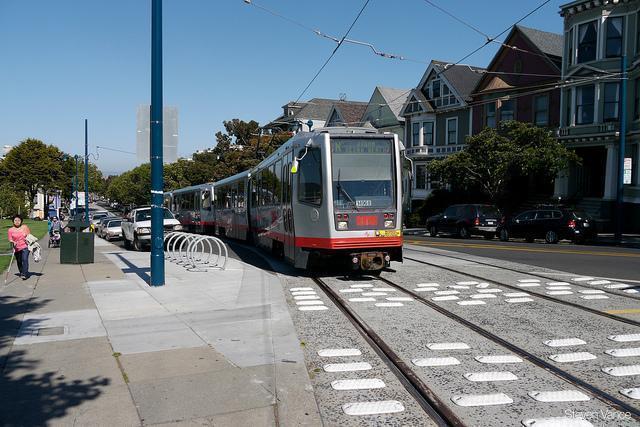The person nearest has what handicap?
Indicate the correct response and explain using: 'Answer: answer
Rationale: rationale.'
Options: Lameness, hearing, heart defect, blindness. Answer: blindness.
Rationale: The person is using a special cane that helps the visually impaired to scan for obstacles in their environment. 